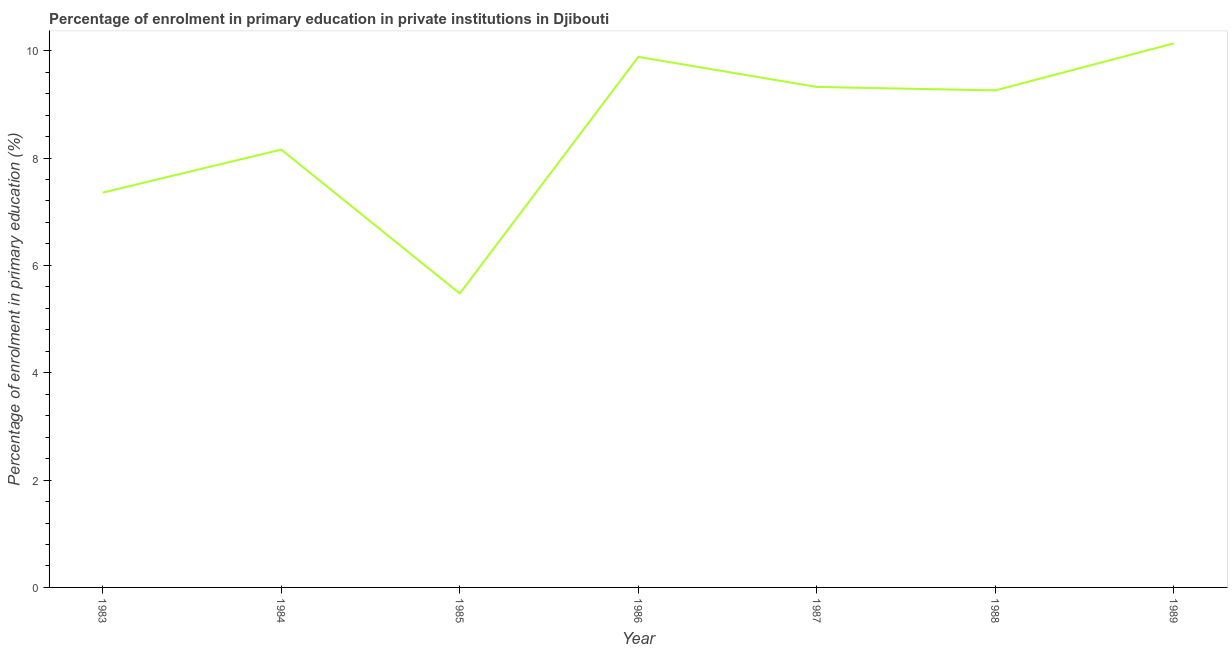What is the enrolment percentage in primary education in 1983?
Offer a terse response. 7.36. Across all years, what is the maximum enrolment percentage in primary education?
Keep it short and to the point. 10.14. Across all years, what is the minimum enrolment percentage in primary education?
Provide a succinct answer. 5.48. What is the sum of the enrolment percentage in primary education?
Your answer should be compact. 59.59. What is the difference between the enrolment percentage in primary education in 1984 and 1987?
Offer a very short reply. -1.17. What is the average enrolment percentage in primary education per year?
Give a very brief answer. 8.51. What is the median enrolment percentage in primary education?
Provide a short and direct response. 9.26. In how many years, is the enrolment percentage in primary education greater than 6.4 %?
Offer a very short reply. 6. Do a majority of the years between 1986 and 1989 (inclusive) have enrolment percentage in primary education greater than 7.2 %?
Provide a short and direct response. Yes. What is the ratio of the enrolment percentage in primary education in 1985 to that in 1987?
Offer a very short reply. 0.59. Is the enrolment percentage in primary education in 1984 less than that in 1989?
Offer a very short reply. Yes. Is the difference between the enrolment percentage in primary education in 1983 and 1986 greater than the difference between any two years?
Keep it short and to the point. No. What is the difference between the highest and the second highest enrolment percentage in primary education?
Offer a very short reply. 0.25. Is the sum of the enrolment percentage in primary education in 1983 and 1984 greater than the maximum enrolment percentage in primary education across all years?
Provide a succinct answer. Yes. What is the difference between the highest and the lowest enrolment percentage in primary education?
Your answer should be compact. 4.66. How many lines are there?
Provide a succinct answer. 1. Does the graph contain any zero values?
Ensure brevity in your answer.  No. Does the graph contain grids?
Ensure brevity in your answer.  No. What is the title of the graph?
Your answer should be very brief. Percentage of enrolment in primary education in private institutions in Djibouti. What is the label or title of the Y-axis?
Make the answer very short. Percentage of enrolment in primary education (%). What is the Percentage of enrolment in primary education (%) of 1983?
Provide a short and direct response. 7.36. What is the Percentage of enrolment in primary education (%) in 1984?
Your response must be concise. 8.16. What is the Percentage of enrolment in primary education (%) in 1985?
Offer a terse response. 5.48. What is the Percentage of enrolment in primary education (%) in 1986?
Provide a succinct answer. 9.88. What is the Percentage of enrolment in primary education (%) in 1987?
Offer a terse response. 9.32. What is the Percentage of enrolment in primary education (%) in 1988?
Give a very brief answer. 9.26. What is the Percentage of enrolment in primary education (%) of 1989?
Make the answer very short. 10.14. What is the difference between the Percentage of enrolment in primary education (%) in 1983 and 1984?
Provide a succinct answer. -0.8. What is the difference between the Percentage of enrolment in primary education (%) in 1983 and 1985?
Keep it short and to the point. 1.88. What is the difference between the Percentage of enrolment in primary education (%) in 1983 and 1986?
Ensure brevity in your answer.  -2.53. What is the difference between the Percentage of enrolment in primary education (%) in 1983 and 1987?
Offer a very short reply. -1.97. What is the difference between the Percentage of enrolment in primary education (%) in 1983 and 1988?
Offer a terse response. -1.9. What is the difference between the Percentage of enrolment in primary education (%) in 1983 and 1989?
Provide a succinct answer. -2.78. What is the difference between the Percentage of enrolment in primary education (%) in 1984 and 1985?
Your response must be concise. 2.68. What is the difference between the Percentage of enrolment in primary education (%) in 1984 and 1986?
Provide a short and direct response. -1.73. What is the difference between the Percentage of enrolment in primary education (%) in 1984 and 1987?
Provide a succinct answer. -1.17. What is the difference between the Percentage of enrolment in primary education (%) in 1984 and 1988?
Provide a short and direct response. -1.1. What is the difference between the Percentage of enrolment in primary education (%) in 1984 and 1989?
Your answer should be compact. -1.98. What is the difference between the Percentage of enrolment in primary education (%) in 1985 and 1986?
Provide a succinct answer. -4.41. What is the difference between the Percentage of enrolment in primary education (%) in 1985 and 1987?
Your response must be concise. -3.85. What is the difference between the Percentage of enrolment in primary education (%) in 1985 and 1988?
Provide a short and direct response. -3.78. What is the difference between the Percentage of enrolment in primary education (%) in 1985 and 1989?
Your response must be concise. -4.66. What is the difference between the Percentage of enrolment in primary education (%) in 1986 and 1987?
Offer a terse response. 0.56. What is the difference between the Percentage of enrolment in primary education (%) in 1986 and 1988?
Give a very brief answer. 0.62. What is the difference between the Percentage of enrolment in primary education (%) in 1986 and 1989?
Your answer should be compact. -0.25. What is the difference between the Percentage of enrolment in primary education (%) in 1987 and 1988?
Ensure brevity in your answer.  0.06. What is the difference between the Percentage of enrolment in primary education (%) in 1987 and 1989?
Provide a succinct answer. -0.81. What is the difference between the Percentage of enrolment in primary education (%) in 1988 and 1989?
Offer a terse response. -0.88. What is the ratio of the Percentage of enrolment in primary education (%) in 1983 to that in 1984?
Provide a succinct answer. 0.9. What is the ratio of the Percentage of enrolment in primary education (%) in 1983 to that in 1985?
Provide a short and direct response. 1.34. What is the ratio of the Percentage of enrolment in primary education (%) in 1983 to that in 1986?
Make the answer very short. 0.74. What is the ratio of the Percentage of enrolment in primary education (%) in 1983 to that in 1987?
Your answer should be very brief. 0.79. What is the ratio of the Percentage of enrolment in primary education (%) in 1983 to that in 1988?
Make the answer very short. 0.79. What is the ratio of the Percentage of enrolment in primary education (%) in 1983 to that in 1989?
Provide a succinct answer. 0.73. What is the ratio of the Percentage of enrolment in primary education (%) in 1984 to that in 1985?
Make the answer very short. 1.49. What is the ratio of the Percentage of enrolment in primary education (%) in 1984 to that in 1986?
Provide a short and direct response. 0.82. What is the ratio of the Percentage of enrolment in primary education (%) in 1984 to that in 1987?
Make the answer very short. 0.88. What is the ratio of the Percentage of enrolment in primary education (%) in 1984 to that in 1988?
Your answer should be compact. 0.88. What is the ratio of the Percentage of enrolment in primary education (%) in 1984 to that in 1989?
Your answer should be compact. 0.81. What is the ratio of the Percentage of enrolment in primary education (%) in 1985 to that in 1986?
Make the answer very short. 0.55. What is the ratio of the Percentage of enrolment in primary education (%) in 1985 to that in 1987?
Your answer should be compact. 0.59. What is the ratio of the Percentage of enrolment in primary education (%) in 1985 to that in 1988?
Make the answer very short. 0.59. What is the ratio of the Percentage of enrolment in primary education (%) in 1985 to that in 1989?
Offer a very short reply. 0.54. What is the ratio of the Percentage of enrolment in primary education (%) in 1986 to that in 1987?
Provide a short and direct response. 1.06. What is the ratio of the Percentage of enrolment in primary education (%) in 1986 to that in 1988?
Your answer should be very brief. 1.07. What is the ratio of the Percentage of enrolment in primary education (%) in 1987 to that in 1988?
Provide a short and direct response. 1.01. What is the ratio of the Percentage of enrolment in primary education (%) in 1988 to that in 1989?
Provide a succinct answer. 0.91. 